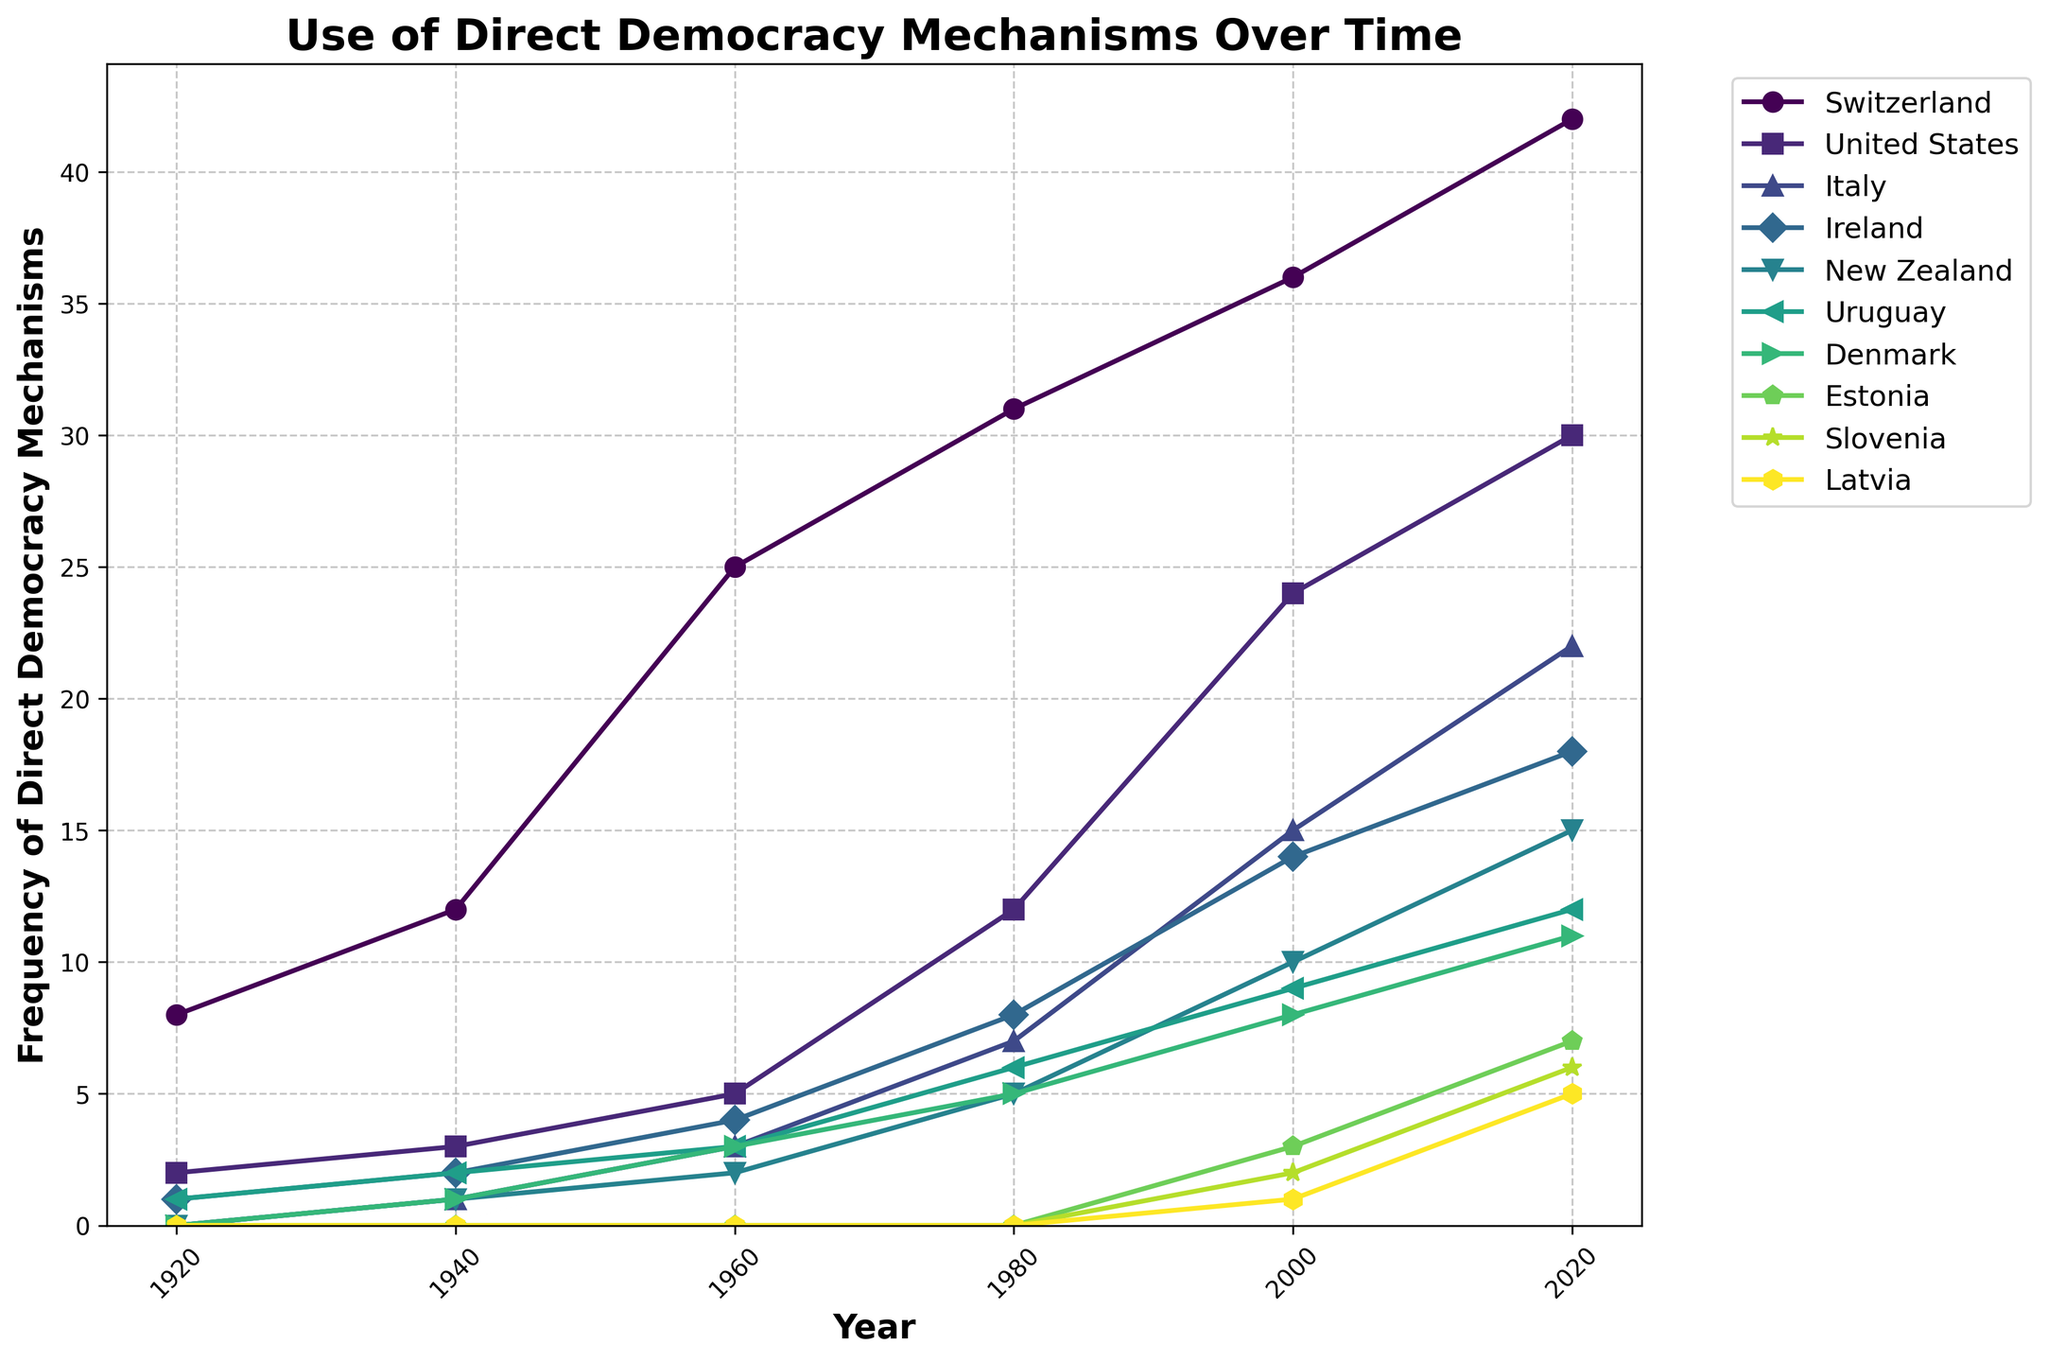Which country had the highest frequency of direct democracy mechanisms in 2020? According to the chart, Switzerland had the highest frequency of 42 mechanisms in 2020, as indicated by the highest position in the corresponding year.
Answer: Switzerland Which two countries had the same frequency of direct democracy mechanisms in 1980? By observing the 1980 markers on the graph, Ireland and Denmark both had 5 mechanisms each, as depicted by their markers at the same height.
Answer: Ireland and Denmark How did the frequency of direct democracy mechanisms change in the United States from 1920 to 2020? In 1920, the United States had 2 mechanisms. This increased to 3 in 1940, 5 in 1960, 12 in 1980, 24 in 2000, and 30 in 2020. The frequency progressively increased over the century.
Answer: Increased Which country showed the most significant increase in frequency of direct democracy mechanisms between 1920 and 2020? Using the visual data, Switzerland exhibited the most significant increase, going from 8 to 42 mechanisms, a difference of 34, which is higher than any other country's increase.
Answer: Switzerland How many more direct democracy mechanisms did Italy have in 2000 compared to 1960? Italy had 15 mechanisms in 2000 and 3 in 1960. The difference is 15 - 3, which equals 12 mechanisms.
Answer: 12 Which countries introduced direct democracy mechanisms after 1980? The markers for Estonia, Slovenia, and Latvia first appear post-1980, indicating they introduced mechanisms later. Estonia first appears in 2000 with 3 mechanisms, Slovenia in 2000 with 2, and Latvia in 2000 with 1.
Answer: Estonia, Slovenia, and Latvia What was the average frequency of direct democracy mechanisms for New Zealand in the years 1960, 1980, and 2000? The frequencies for New Zealand in these years are 2, 5, and 10 respectively. Sum them to get 2 + 5 + 10 = 17, then divide by 3 to find the average: 17 / 3 ≈ 5.67.
Answer: 5.67 Which country had the smallest range in the frequency of direct democracy mechanisms over the century? Uruguay ranged from 1 mechanism in 1920 to 12 in 2020, giving it a range of 12 - 1 = 11. This is the smallest range among all the countries shown.
Answer: Uruguay 